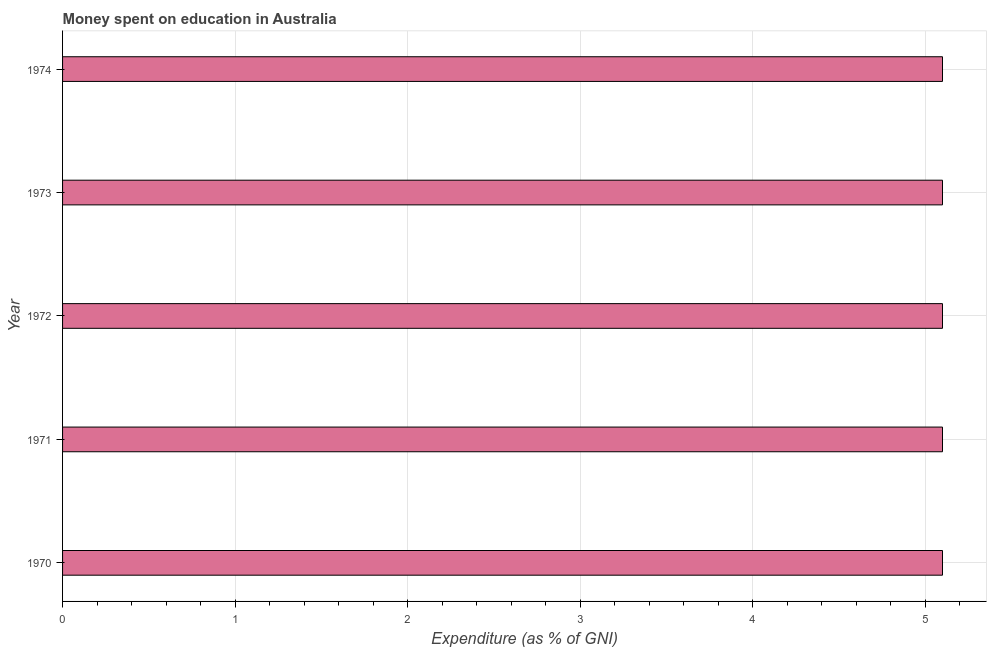Does the graph contain any zero values?
Your answer should be compact. No. What is the title of the graph?
Offer a terse response. Money spent on education in Australia. What is the label or title of the X-axis?
Offer a very short reply. Expenditure (as % of GNI). What is the label or title of the Y-axis?
Your response must be concise. Year. What is the expenditure on education in 1974?
Offer a very short reply. 5.1. Across all years, what is the minimum expenditure on education?
Offer a terse response. 5.1. In how many years, is the expenditure on education greater than 2.6 %?
Give a very brief answer. 5. What is the ratio of the expenditure on education in 1970 to that in 1973?
Ensure brevity in your answer.  1. Is the difference between the expenditure on education in 1970 and 1974 greater than the difference between any two years?
Provide a short and direct response. Yes. Is the sum of the expenditure on education in 1970 and 1972 greater than the maximum expenditure on education across all years?
Ensure brevity in your answer.  Yes. How many years are there in the graph?
Provide a succinct answer. 5. Are the values on the major ticks of X-axis written in scientific E-notation?
Your answer should be very brief. No. What is the Expenditure (as % of GNI) of 1972?
Make the answer very short. 5.1. What is the Expenditure (as % of GNI) in 1973?
Keep it short and to the point. 5.1. What is the Expenditure (as % of GNI) in 1974?
Provide a succinct answer. 5.1. What is the difference between the Expenditure (as % of GNI) in 1970 and 1971?
Your response must be concise. 0. What is the difference between the Expenditure (as % of GNI) in 1970 and 1972?
Ensure brevity in your answer.  0. What is the difference between the Expenditure (as % of GNI) in 1970 and 1973?
Your answer should be compact. 0. What is the difference between the Expenditure (as % of GNI) in 1971 and 1972?
Offer a terse response. 0. What is the difference between the Expenditure (as % of GNI) in 1971 and 1973?
Give a very brief answer. 0. What is the difference between the Expenditure (as % of GNI) in 1972 and 1973?
Provide a short and direct response. 0. What is the ratio of the Expenditure (as % of GNI) in 1970 to that in 1972?
Your answer should be very brief. 1. What is the ratio of the Expenditure (as % of GNI) in 1970 to that in 1973?
Your answer should be compact. 1. What is the ratio of the Expenditure (as % of GNI) in 1970 to that in 1974?
Give a very brief answer. 1. What is the ratio of the Expenditure (as % of GNI) in 1971 to that in 1973?
Your answer should be compact. 1. What is the ratio of the Expenditure (as % of GNI) in 1972 to that in 1974?
Ensure brevity in your answer.  1. 